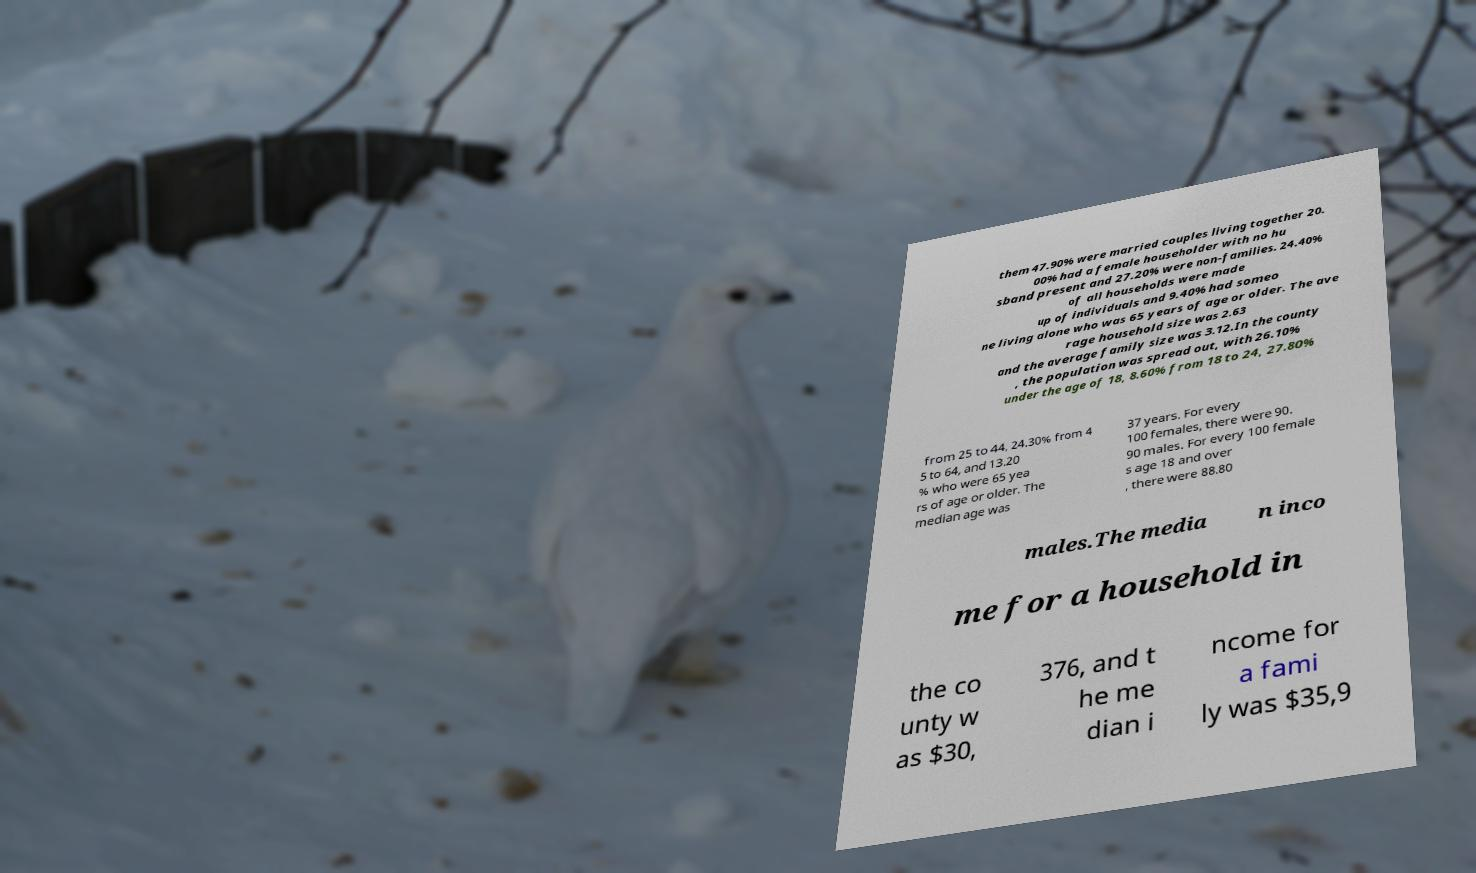What messages or text are displayed in this image? I need them in a readable, typed format. them 47.90% were married couples living together 20. 00% had a female householder with no hu sband present and 27.20% were non-families. 24.40% of all households were made up of individuals and 9.40% had someo ne living alone who was 65 years of age or older. The ave rage household size was 2.63 and the average family size was 3.12.In the county , the population was spread out, with 26.10% under the age of 18, 8.60% from 18 to 24, 27.80% from 25 to 44, 24.30% from 4 5 to 64, and 13.20 % who were 65 yea rs of age or older. The median age was 37 years. For every 100 females, there were 90. 90 males. For every 100 female s age 18 and over , there were 88.80 males.The media n inco me for a household in the co unty w as $30, 376, and t he me dian i ncome for a fami ly was $35,9 